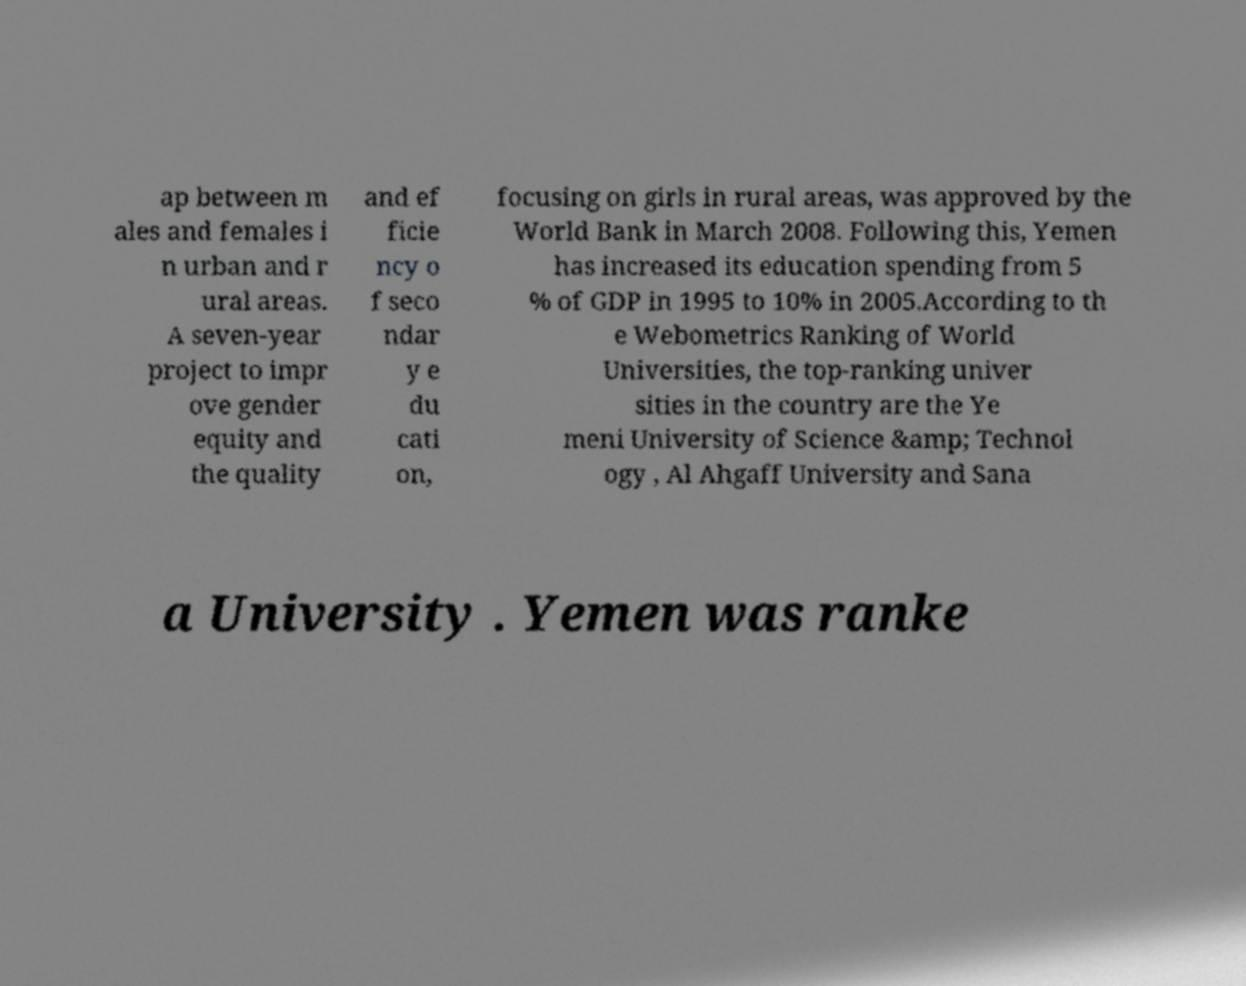Please read and relay the text visible in this image. What does it say? ap between m ales and females i n urban and r ural areas. A seven-year project to impr ove gender equity and the quality and ef ficie ncy o f seco ndar y e du cati on, focusing on girls in rural areas, was approved by the World Bank in March 2008. Following this, Yemen has increased its education spending from 5 % of GDP in 1995 to 10% in 2005.According to th e Webometrics Ranking of World Universities, the top-ranking univer sities in the country are the Ye meni University of Science &amp; Technol ogy , Al Ahgaff University and Sana a University . Yemen was ranke 